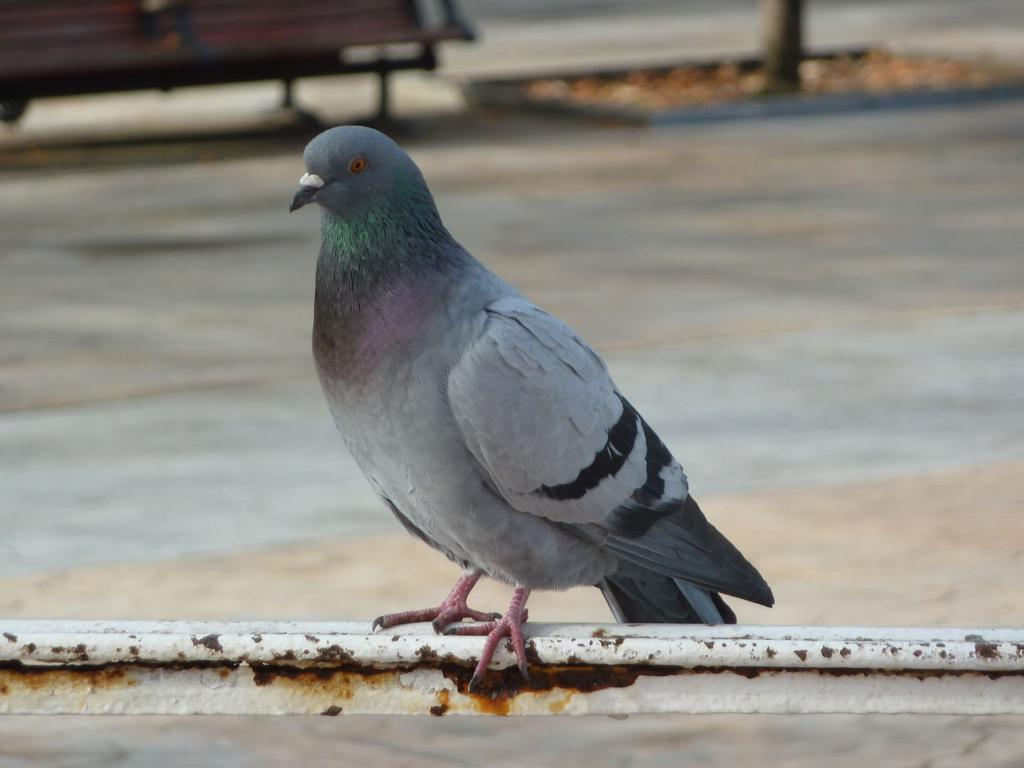What is the main subject in the foreground of the picture? There is a pigeon in the foreground of the picture. Where is the pigeon located? The pigeon is on an iron bar. Can you describe the background of the image? The background of the image is blurred, but there is a pavement, a bench, a tree, and dry leaves visible. How many pigs are visible in the image? There are no pigs present in the image. Is there a beggar sitting on the bench in the background of the image? There is no beggar visible in the image; only the pigeon, iron bar, pavement, bench, tree, and dry leaves can be seen. 